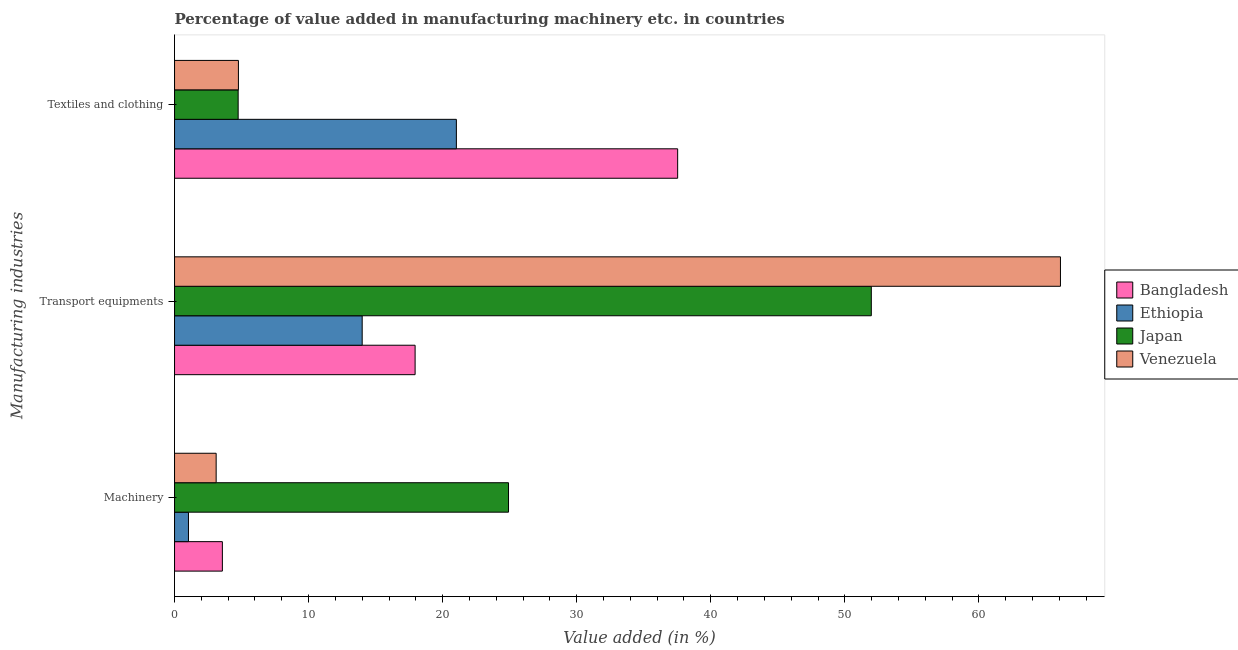How many groups of bars are there?
Provide a succinct answer. 3. What is the label of the 3rd group of bars from the top?
Ensure brevity in your answer.  Machinery. What is the value added in manufacturing transport equipments in Venezuela?
Keep it short and to the point. 66.08. Across all countries, what is the maximum value added in manufacturing textile and clothing?
Keep it short and to the point. 37.53. Across all countries, what is the minimum value added in manufacturing machinery?
Offer a terse response. 1.04. In which country was the value added in manufacturing transport equipments maximum?
Offer a terse response. Venezuela. In which country was the value added in manufacturing machinery minimum?
Give a very brief answer. Ethiopia. What is the total value added in manufacturing machinery in the graph?
Offer a very short reply. 32.62. What is the difference between the value added in manufacturing machinery in Ethiopia and that in Venezuela?
Your answer should be very brief. -2.06. What is the difference between the value added in manufacturing textile and clothing in Ethiopia and the value added in manufacturing machinery in Venezuela?
Offer a terse response. 17.92. What is the average value added in manufacturing textile and clothing per country?
Give a very brief answer. 17.02. What is the difference between the value added in manufacturing transport equipments and value added in manufacturing machinery in Japan?
Ensure brevity in your answer.  27.06. What is the ratio of the value added in manufacturing machinery in Ethiopia to that in Japan?
Offer a very short reply. 0.04. Is the value added in manufacturing textile and clothing in Japan less than that in Ethiopia?
Offer a terse response. Yes. Is the difference between the value added in manufacturing transport equipments in Ethiopia and Bangladesh greater than the difference between the value added in manufacturing textile and clothing in Ethiopia and Bangladesh?
Your response must be concise. Yes. What is the difference between the highest and the second highest value added in manufacturing transport equipments?
Provide a short and direct response. 14.11. What is the difference between the highest and the lowest value added in manufacturing textile and clothing?
Your response must be concise. 32.78. In how many countries, is the value added in manufacturing transport equipments greater than the average value added in manufacturing transport equipments taken over all countries?
Your answer should be very brief. 2. Is the sum of the value added in manufacturing textile and clothing in Venezuela and Ethiopia greater than the maximum value added in manufacturing transport equipments across all countries?
Your answer should be very brief. No. What does the 2nd bar from the bottom in Transport equipments represents?
Provide a succinct answer. Ethiopia. Is it the case that in every country, the sum of the value added in manufacturing machinery and value added in manufacturing transport equipments is greater than the value added in manufacturing textile and clothing?
Make the answer very short. No. How many bars are there?
Provide a succinct answer. 12. How many countries are there in the graph?
Your response must be concise. 4. Does the graph contain any zero values?
Your answer should be very brief. No. How many legend labels are there?
Your response must be concise. 4. What is the title of the graph?
Provide a succinct answer. Percentage of value added in manufacturing machinery etc. in countries. Does "Malawi" appear as one of the legend labels in the graph?
Provide a succinct answer. No. What is the label or title of the X-axis?
Your answer should be very brief. Value added (in %). What is the label or title of the Y-axis?
Your answer should be compact. Manufacturing industries. What is the Value added (in %) of Bangladesh in Machinery?
Provide a short and direct response. 3.57. What is the Value added (in %) of Ethiopia in Machinery?
Your answer should be compact. 1.04. What is the Value added (in %) in Japan in Machinery?
Your answer should be compact. 24.91. What is the Value added (in %) of Venezuela in Machinery?
Keep it short and to the point. 3.1. What is the Value added (in %) in Bangladesh in Transport equipments?
Offer a terse response. 17.94. What is the Value added (in %) in Ethiopia in Transport equipments?
Give a very brief answer. 14. What is the Value added (in %) of Japan in Transport equipments?
Your answer should be compact. 51.97. What is the Value added (in %) of Venezuela in Transport equipments?
Provide a succinct answer. 66.08. What is the Value added (in %) of Bangladesh in Textiles and clothing?
Give a very brief answer. 37.53. What is the Value added (in %) of Ethiopia in Textiles and clothing?
Your response must be concise. 21.02. What is the Value added (in %) of Japan in Textiles and clothing?
Keep it short and to the point. 4.74. What is the Value added (in %) of Venezuela in Textiles and clothing?
Offer a terse response. 4.76. Across all Manufacturing industries, what is the maximum Value added (in %) of Bangladesh?
Your answer should be very brief. 37.53. Across all Manufacturing industries, what is the maximum Value added (in %) of Ethiopia?
Your response must be concise. 21.02. Across all Manufacturing industries, what is the maximum Value added (in %) of Japan?
Your answer should be compact. 51.97. Across all Manufacturing industries, what is the maximum Value added (in %) of Venezuela?
Your response must be concise. 66.08. Across all Manufacturing industries, what is the minimum Value added (in %) of Bangladesh?
Provide a short and direct response. 3.57. Across all Manufacturing industries, what is the minimum Value added (in %) of Ethiopia?
Offer a very short reply. 1.04. Across all Manufacturing industries, what is the minimum Value added (in %) in Japan?
Provide a short and direct response. 4.74. Across all Manufacturing industries, what is the minimum Value added (in %) in Venezuela?
Your response must be concise. 3.1. What is the total Value added (in %) of Bangladesh in the graph?
Provide a short and direct response. 59.04. What is the total Value added (in %) of Ethiopia in the graph?
Offer a terse response. 36.06. What is the total Value added (in %) of Japan in the graph?
Give a very brief answer. 81.63. What is the total Value added (in %) in Venezuela in the graph?
Provide a short and direct response. 73.95. What is the difference between the Value added (in %) of Bangladesh in Machinery and that in Transport equipments?
Give a very brief answer. -14.38. What is the difference between the Value added (in %) of Ethiopia in Machinery and that in Transport equipments?
Your answer should be compact. -12.96. What is the difference between the Value added (in %) in Japan in Machinery and that in Transport equipments?
Provide a short and direct response. -27.06. What is the difference between the Value added (in %) in Venezuela in Machinery and that in Transport equipments?
Your answer should be compact. -62.98. What is the difference between the Value added (in %) in Bangladesh in Machinery and that in Textiles and clothing?
Make the answer very short. -33.96. What is the difference between the Value added (in %) in Ethiopia in Machinery and that in Textiles and clothing?
Provide a succinct answer. -19.98. What is the difference between the Value added (in %) of Japan in Machinery and that in Textiles and clothing?
Your answer should be compact. 20.17. What is the difference between the Value added (in %) in Venezuela in Machinery and that in Textiles and clothing?
Ensure brevity in your answer.  -1.66. What is the difference between the Value added (in %) in Bangladesh in Transport equipments and that in Textiles and clothing?
Provide a succinct answer. -19.58. What is the difference between the Value added (in %) in Ethiopia in Transport equipments and that in Textiles and clothing?
Ensure brevity in your answer.  -7.03. What is the difference between the Value added (in %) of Japan in Transport equipments and that in Textiles and clothing?
Provide a short and direct response. 47.23. What is the difference between the Value added (in %) in Venezuela in Transport equipments and that in Textiles and clothing?
Offer a very short reply. 61.32. What is the difference between the Value added (in %) of Bangladesh in Machinery and the Value added (in %) of Ethiopia in Transport equipments?
Keep it short and to the point. -10.43. What is the difference between the Value added (in %) of Bangladesh in Machinery and the Value added (in %) of Japan in Transport equipments?
Offer a terse response. -48.41. What is the difference between the Value added (in %) of Bangladesh in Machinery and the Value added (in %) of Venezuela in Transport equipments?
Provide a succinct answer. -62.52. What is the difference between the Value added (in %) of Ethiopia in Machinery and the Value added (in %) of Japan in Transport equipments?
Your answer should be compact. -50.94. What is the difference between the Value added (in %) of Ethiopia in Machinery and the Value added (in %) of Venezuela in Transport equipments?
Make the answer very short. -65.04. What is the difference between the Value added (in %) in Japan in Machinery and the Value added (in %) in Venezuela in Transport equipments?
Keep it short and to the point. -41.17. What is the difference between the Value added (in %) of Bangladesh in Machinery and the Value added (in %) of Ethiopia in Textiles and clothing?
Your answer should be compact. -17.46. What is the difference between the Value added (in %) in Bangladesh in Machinery and the Value added (in %) in Japan in Textiles and clothing?
Offer a terse response. -1.18. What is the difference between the Value added (in %) in Bangladesh in Machinery and the Value added (in %) in Venezuela in Textiles and clothing?
Offer a very short reply. -1.2. What is the difference between the Value added (in %) of Ethiopia in Machinery and the Value added (in %) of Japan in Textiles and clothing?
Offer a very short reply. -3.71. What is the difference between the Value added (in %) in Ethiopia in Machinery and the Value added (in %) in Venezuela in Textiles and clothing?
Offer a very short reply. -3.73. What is the difference between the Value added (in %) in Japan in Machinery and the Value added (in %) in Venezuela in Textiles and clothing?
Ensure brevity in your answer.  20.15. What is the difference between the Value added (in %) of Bangladesh in Transport equipments and the Value added (in %) of Ethiopia in Textiles and clothing?
Ensure brevity in your answer.  -3.08. What is the difference between the Value added (in %) of Bangladesh in Transport equipments and the Value added (in %) of Japan in Textiles and clothing?
Ensure brevity in your answer.  13.2. What is the difference between the Value added (in %) in Bangladesh in Transport equipments and the Value added (in %) in Venezuela in Textiles and clothing?
Give a very brief answer. 13.18. What is the difference between the Value added (in %) in Ethiopia in Transport equipments and the Value added (in %) in Japan in Textiles and clothing?
Your answer should be very brief. 9.25. What is the difference between the Value added (in %) of Ethiopia in Transport equipments and the Value added (in %) of Venezuela in Textiles and clothing?
Keep it short and to the point. 9.23. What is the difference between the Value added (in %) of Japan in Transport equipments and the Value added (in %) of Venezuela in Textiles and clothing?
Offer a terse response. 47.21. What is the average Value added (in %) in Bangladesh per Manufacturing industries?
Give a very brief answer. 19.68. What is the average Value added (in %) of Ethiopia per Manufacturing industries?
Make the answer very short. 12.02. What is the average Value added (in %) of Japan per Manufacturing industries?
Make the answer very short. 27.21. What is the average Value added (in %) in Venezuela per Manufacturing industries?
Your answer should be compact. 24.65. What is the difference between the Value added (in %) in Bangladesh and Value added (in %) in Ethiopia in Machinery?
Make the answer very short. 2.53. What is the difference between the Value added (in %) of Bangladesh and Value added (in %) of Japan in Machinery?
Your answer should be very brief. -21.34. What is the difference between the Value added (in %) in Bangladesh and Value added (in %) in Venezuela in Machinery?
Offer a very short reply. 0.46. What is the difference between the Value added (in %) of Ethiopia and Value added (in %) of Japan in Machinery?
Keep it short and to the point. -23.87. What is the difference between the Value added (in %) in Ethiopia and Value added (in %) in Venezuela in Machinery?
Your answer should be compact. -2.06. What is the difference between the Value added (in %) in Japan and Value added (in %) in Venezuela in Machinery?
Make the answer very short. 21.81. What is the difference between the Value added (in %) of Bangladesh and Value added (in %) of Ethiopia in Transport equipments?
Give a very brief answer. 3.95. What is the difference between the Value added (in %) in Bangladesh and Value added (in %) in Japan in Transport equipments?
Your response must be concise. -34.03. What is the difference between the Value added (in %) of Bangladesh and Value added (in %) of Venezuela in Transport equipments?
Provide a short and direct response. -48.14. What is the difference between the Value added (in %) in Ethiopia and Value added (in %) in Japan in Transport equipments?
Give a very brief answer. -37.98. What is the difference between the Value added (in %) of Ethiopia and Value added (in %) of Venezuela in Transport equipments?
Provide a succinct answer. -52.09. What is the difference between the Value added (in %) in Japan and Value added (in %) in Venezuela in Transport equipments?
Your response must be concise. -14.11. What is the difference between the Value added (in %) in Bangladesh and Value added (in %) in Ethiopia in Textiles and clothing?
Keep it short and to the point. 16.51. What is the difference between the Value added (in %) in Bangladesh and Value added (in %) in Japan in Textiles and clothing?
Provide a short and direct response. 32.78. What is the difference between the Value added (in %) in Bangladesh and Value added (in %) in Venezuela in Textiles and clothing?
Offer a terse response. 32.76. What is the difference between the Value added (in %) in Ethiopia and Value added (in %) in Japan in Textiles and clothing?
Your response must be concise. 16.28. What is the difference between the Value added (in %) in Ethiopia and Value added (in %) in Venezuela in Textiles and clothing?
Keep it short and to the point. 16.26. What is the difference between the Value added (in %) of Japan and Value added (in %) of Venezuela in Textiles and clothing?
Your response must be concise. -0.02. What is the ratio of the Value added (in %) of Bangladesh in Machinery to that in Transport equipments?
Give a very brief answer. 0.2. What is the ratio of the Value added (in %) in Ethiopia in Machinery to that in Transport equipments?
Provide a succinct answer. 0.07. What is the ratio of the Value added (in %) in Japan in Machinery to that in Transport equipments?
Give a very brief answer. 0.48. What is the ratio of the Value added (in %) in Venezuela in Machinery to that in Transport equipments?
Your answer should be compact. 0.05. What is the ratio of the Value added (in %) in Bangladesh in Machinery to that in Textiles and clothing?
Give a very brief answer. 0.1. What is the ratio of the Value added (in %) of Ethiopia in Machinery to that in Textiles and clothing?
Give a very brief answer. 0.05. What is the ratio of the Value added (in %) of Japan in Machinery to that in Textiles and clothing?
Give a very brief answer. 5.25. What is the ratio of the Value added (in %) of Venezuela in Machinery to that in Textiles and clothing?
Keep it short and to the point. 0.65. What is the ratio of the Value added (in %) of Bangladesh in Transport equipments to that in Textiles and clothing?
Ensure brevity in your answer.  0.48. What is the ratio of the Value added (in %) in Ethiopia in Transport equipments to that in Textiles and clothing?
Provide a short and direct response. 0.67. What is the ratio of the Value added (in %) in Japan in Transport equipments to that in Textiles and clothing?
Your response must be concise. 10.95. What is the ratio of the Value added (in %) in Venezuela in Transport equipments to that in Textiles and clothing?
Provide a short and direct response. 13.87. What is the difference between the highest and the second highest Value added (in %) in Bangladesh?
Offer a terse response. 19.58. What is the difference between the highest and the second highest Value added (in %) in Ethiopia?
Ensure brevity in your answer.  7.03. What is the difference between the highest and the second highest Value added (in %) in Japan?
Offer a very short reply. 27.06. What is the difference between the highest and the second highest Value added (in %) in Venezuela?
Keep it short and to the point. 61.32. What is the difference between the highest and the lowest Value added (in %) of Bangladesh?
Give a very brief answer. 33.96. What is the difference between the highest and the lowest Value added (in %) in Ethiopia?
Provide a short and direct response. 19.98. What is the difference between the highest and the lowest Value added (in %) in Japan?
Offer a very short reply. 47.23. What is the difference between the highest and the lowest Value added (in %) in Venezuela?
Keep it short and to the point. 62.98. 